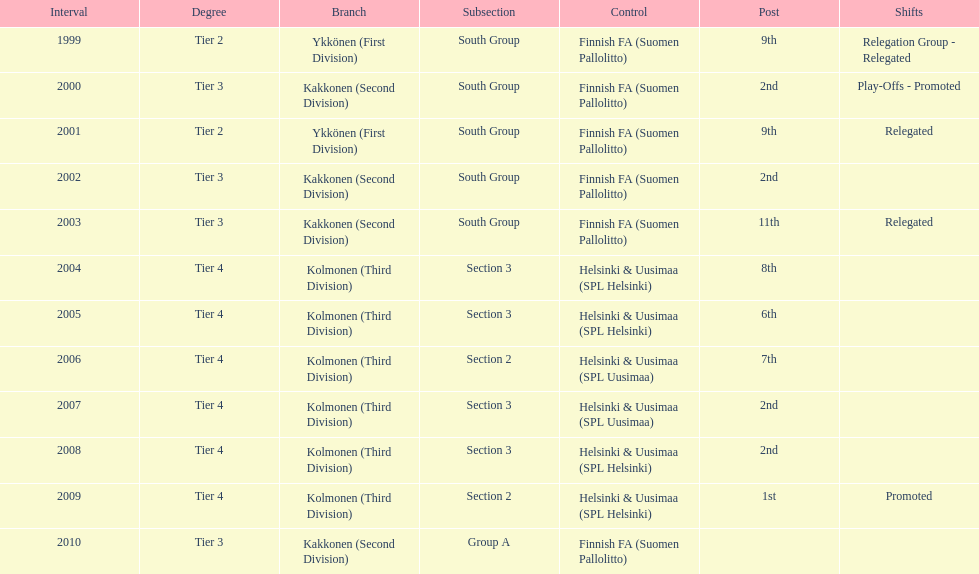How many tiers had more than one relegated movement? 1. 